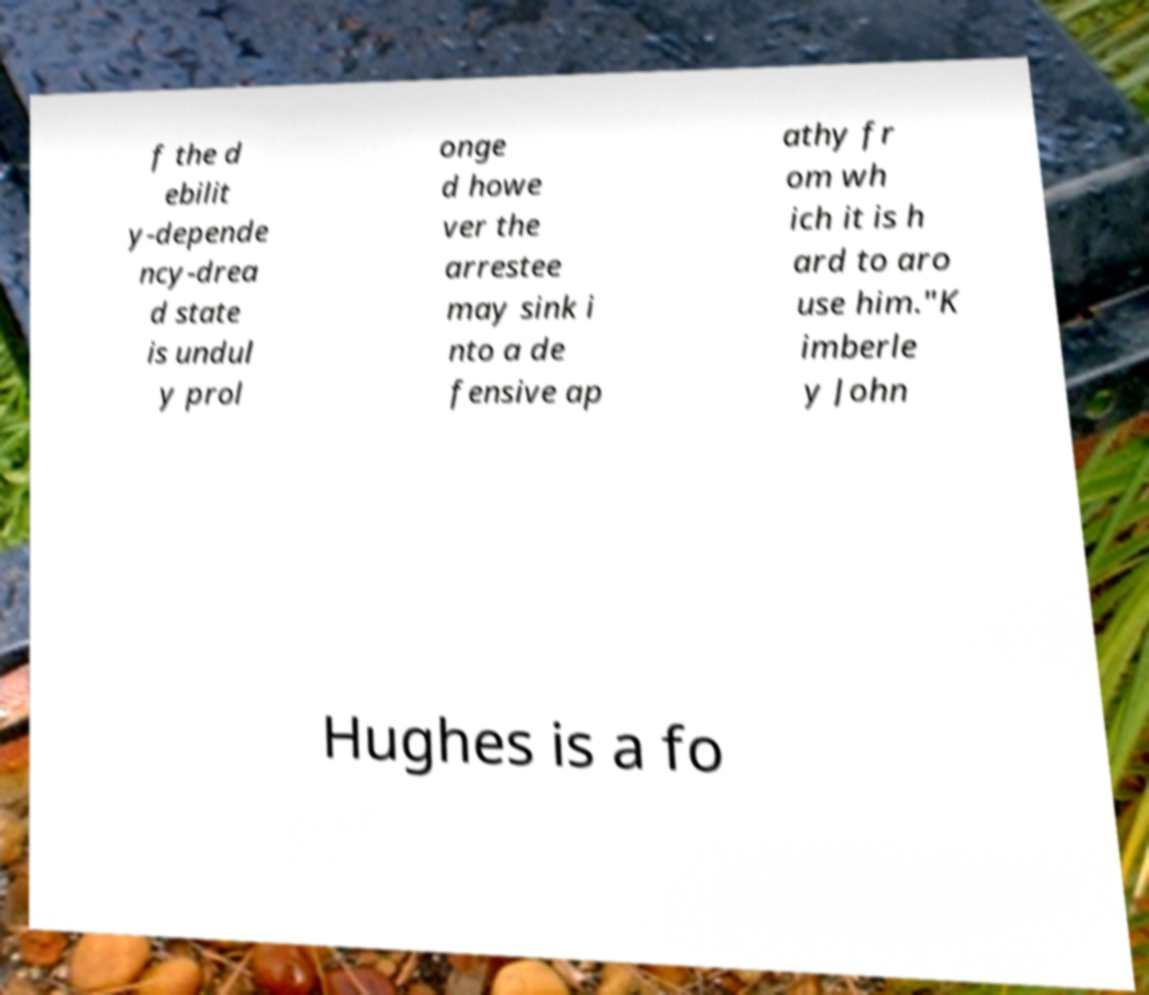Can you accurately transcribe the text from the provided image for me? f the d ebilit y-depende ncy-drea d state is undul y prol onge d howe ver the arrestee may sink i nto a de fensive ap athy fr om wh ich it is h ard to aro use him."K imberle y John Hughes is a fo 